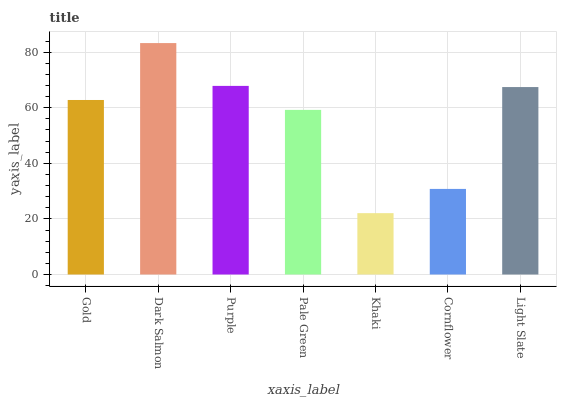Is Khaki the minimum?
Answer yes or no. Yes. Is Dark Salmon the maximum?
Answer yes or no. Yes. Is Purple the minimum?
Answer yes or no. No. Is Purple the maximum?
Answer yes or no. No. Is Dark Salmon greater than Purple?
Answer yes or no. Yes. Is Purple less than Dark Salmon?
Answer yes or no. Yes. Is Purple greater than Dark Salmon?
Answer yes or no. No. Is Dark Salmon less than Purple?
Answer yes or no. No. Is Gold the high median?
Answer yes or no. Yes. Is Gold the low median?
Answer yes or no. Yes. Is Pale Green the high median?
Answer yes or no. No. Is Light Slate the low median?
Answer yes or no. No. 